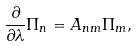Convert formula to latex. <formula><loc_0><loc_0><loc_500><loc_500>\frac { \partial } { \partial \lambda } \Pi _ { n } = A _ { n m } \Pi _ { m } ,</formula> 